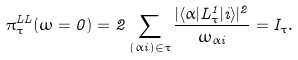<formula> <loc_0><loc_0><loc_500><loc_500>\pi _ { \tau } ^ { L L } ( \omega = 0 ) = 2 \sum _ { ( \alpha i ) \in \tau } \frac { | \langle \alpha | L ^ { 1 } _ { \tau } | i \rangle | ^ { 2 } } { \omega _ { \alpha i } } = I _ { \tau } .</formula> 